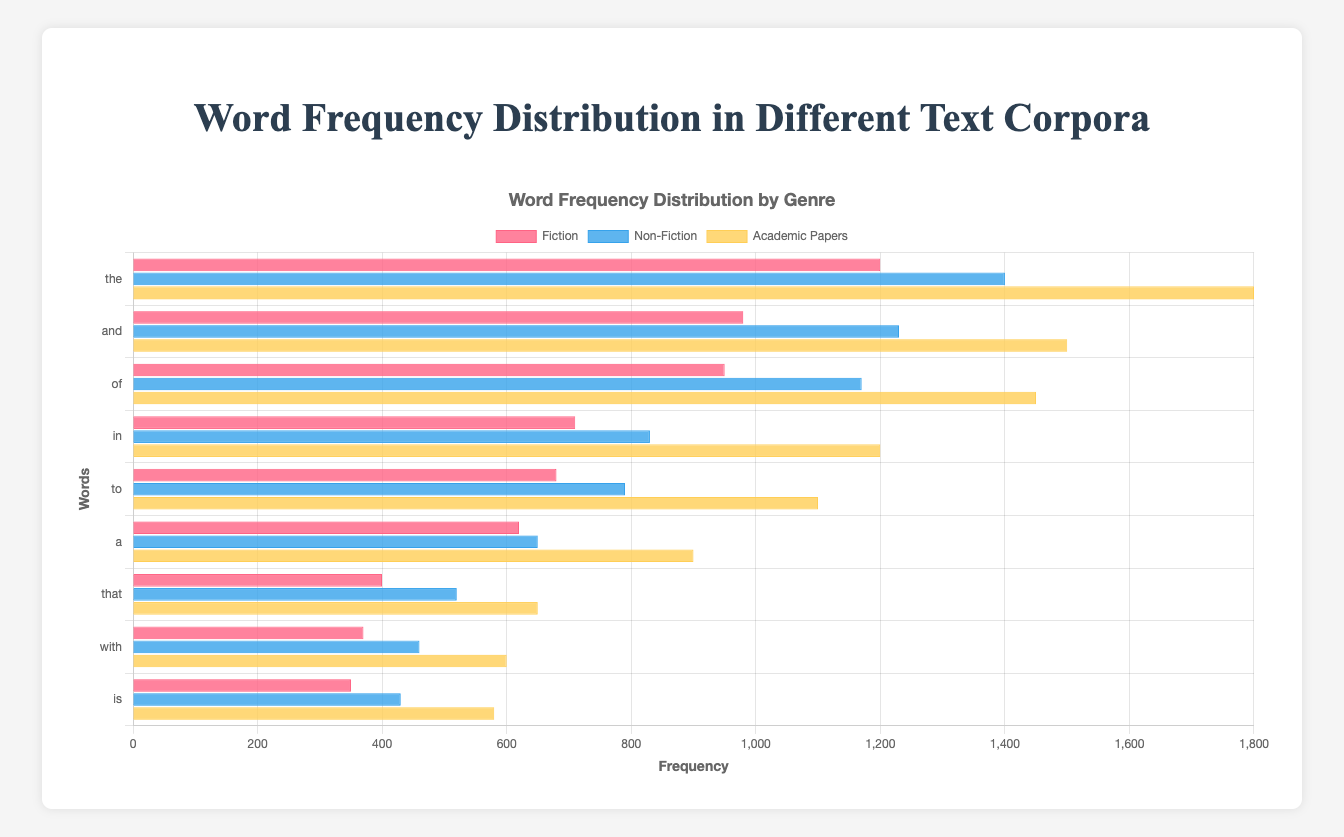What is the total frequency of the word "the" across all genres? To find the total frequency of the word "the", sum its frequencies in each genre: Fiction (1200) + Non-Fiction (1400) + Academic Papers (1800). The steps are 1200 + 1400 = 2600, and 2600 + 1800 = 4400.
Answer: 4400 Which genre has the highest frequency for the word "and"? Compare the frequencies of "and" across the genres: Fiction (980), Non-Fiction (1230), and Academic Papers (1500). Academic Papers has the highest frequency.
Answer: Academic Papers Does the word "with" have a higher frequency in Fiction or Non-Fiction? Compare the frequencies: Fiction (370) and Non-Fiction (460). Non-Fiction has a higher frequency.
Answer: Non-Fiction What is the average frequency of the word "to" across all genres? Sum the frequencies of "to" in all genres: Fiction (680), Non-Fiction (790), and Academic Papers (1100), then divide by 3. The steps are 680 + 790 = 1470, and 1470 + 1100 = 2570. Finally, 2570 / 3 = 856.67.
Answer: 856.67 Which word has the lowest frequency in Academic Papers? Look at the frequencies of words in Academic Papers and identify the lowest value: "the" (1800), "and" (1500), "of" (1450), "in" (1200), "to" (1100), "a" (900), "that" (650), "with" (600), and "is" (580). "is" has the lowest frequency.
Answer: is What is the combined frequency of the words "a" and "that" in Fiction? Sum the frequencies of "a" (620) and "that" (400) in Fiction. The steps are 620 + 400 = 1020.
Answer: 1020 How much higher is the frequency of the word "of" in Academic Papers compared to Fiction? Subtract the frequency of "of" in Fiction (950) from its frequency in Academic Papers (1450). The steps are 1450 - 950 = 500.
Answer: 500 Is the frequency of the word "in" greater than 1000 in any genre? Check the frequencies of "in" in each genre: Fiction (710), Non-Fiction (830), and Academic Papers (1200). It is greater than 1000 in Academic Papers.
Answer: Yes Which genre uses the word "that" the least? Compare the frequencies of "that" across all genres: Fiction (400), Non-Fiction (520), and Academic Papers (650). Fiction has the lowest frequency.
Answer: Fiction What is the difference in frequency for the word "is" between Fiction and Non-Fiction? Subtract the frequency of "is" in Fiction (350) from its frequency in Non-Fiction (430). The steps are 430 - 350 = 80.
Answer: 80 